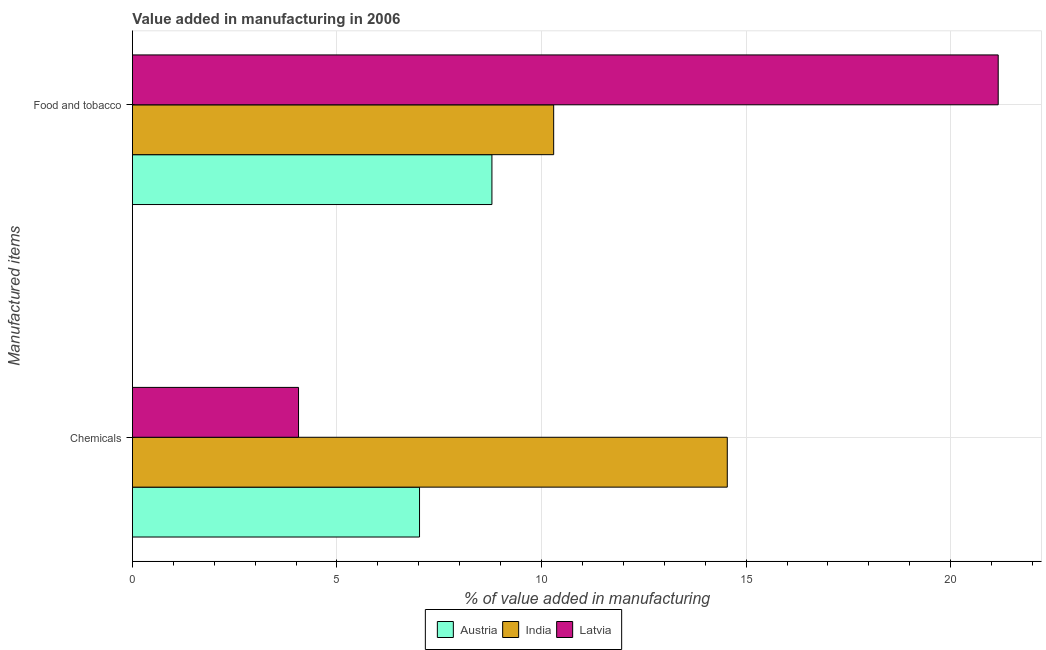How many different coloured bars are there?
Offer a very short reply. 3. Are the number of bars on each tick of the Y-axis equal?
Provide a short and direct response. Yes. How many bars are there on the 2nd tick from the top?
Keep it short and to the point. 3. What is the label of the 1st group of bars from the top?
Your answer should be compact. Food and tobacco. What is the value added by manufacturing food and tobacco in Austria?
Ensure brevity in your answer.  8.79. Across all countries, what is the maximum value added by manufacturing food and tobacco?
Your answer should be very brief. 21.16. Across all countries, what is the minimum value added by  manufacturing chemicals?
Ensure brevity in your answer.  4.06. In which country was the value added by  manufacturing chemicals maximum?
Your answer should be very brief. India. In which country was the value added by  manufacturing chemicals minimum?
Your answer should be very brief. Latvia. What is the total value added by manufacturing food and tobacco in the graph?
Offer a very short reply. 40.25. What is the difference between the value added by  manufacturing chemicals in Latvia and that in India?
Provide a succinct answer. -10.48. What is the difference between the value added by  manufacturing chemicals in Austria and the value added by manufacturing food and tobacco in Latvia?
Provide a succinct answer. -14.15. What is the average value added by manufacturing food and tobacco per country?
Your response must be concise. 13.42. What is the difference between the value added by  manufacturing chemicals and value added by manufacturing food and tobacco in Latvia?
Your answer should be very brief. -17.1. What is the ratio of the value added by  manufacturing chemicals in India to that in Austria?
Give a very brief answer. 2.07. Is the value added by  manufacturing chemicals in India less than that in Latvia?
Your answer should be compact. No. What does the 2nd bar from the top in Food and tobacco represents?
Offer a terse response. India. How many countries are there in the graph?
Your answer should be compact. 3. Are the values on the major ticks of X-axis written in scientific E-notation?
Make the answer very short. No. How many legend labels are there?
Your answer should be compact. 3. What is the title of the graph?
Keep it short and to the point. Value added in manufacturing in 2006. What is the label or title of the X-axis?
Your answer should be compact. % of value added in manufacturing. What is the label or title of the Y-axis?
Your answer should be compact. Manufactured items. What is the % of value added in manufacturing of Austria in Chemicals?
Provide a succinct answer. 7.02. What is the % of value added in manufacturing of India in Chemicals?
Ensure brevity in your answer.  14.54. What is the % of value added in manufacturing of Latvia in Chemicals?
Provide a succinct answer. 4.06. What is the % of value added in manufacturing in Austria in Food and tobacco?
Your answer should be very brief. 8.79. What is the % of value added in manufacturing of India in Food and tobacco?
Provide a succinct answer. 10.3. What is the % of value added in manufacturing in Latvia in Food and tobacco?
Offer a very short reply. 21.16. Across all Manufactured items, what is the maximum % of value added in manufacturing in Austria?
Make the answer very short. 8.79. Across all Manufactured items, what is the maximum % of value added in manufacturing in India?
Ensure brevity in your answer.  14.54. Across all Manufactured items, what is the maximum % of value added in manufacturing of Latvia?
Your answer should be compact. 21.16. Across all Manufactured items, what is the minimum % of value added in manufacturing in Austria?
Provide a short and direct response. 7.02. Across all Manufactured items, what is the minimum % of value added in manufacturing of India?
Provide a succinct answer. 10.3. Across all Manufactured items, what is the minimum % of value added in manufacturing of Latvia?
Offer a terse response. 4.06. What is the total % of value added in manufacturing in Austria in the graph?
Give a very brief answer. 15.8. What is the total % of value added in manufacturing in India in the graph?
Keep it short and to the point. 24.84. What is the total % of value added in manufacturing in Latvia in the graph?
Your answer should be very brief. 25.22. What is the difference between the % of value added in manufacturing in Austria in Chemicals and that in Food and tobacco?
Give a very brief answer. -1.77. What is the difference between the % of value added in manufacturing of India in Chemicals and that in Food and tobacco?
Give a very brief answer. 4.24. What is the difference between the % of value added in manufacturing in Latvia in Chemicals and that in Food and tobacco?
Make the answer very short. -17.1. What is the difference between the % of value added in manufacturing in Austria in Chemicals and the % of value added in manufacturing in India in Food and tobacco?
Your response must be concise. -3.28. What is the difference between the % of value added in manufacturing of Austria in Chemicals and the % of value added in manufacturing of Latvia in Food and tobacco?
Provide a succinct answer. -14.15. What is the difference between the % of value added in manufacturing in India in Chemicals and the % of value added in manufacturing in Latvia in Food and tobacco?
Give a very brief answer. -6.62. What is the average % of value added in manufacturing of Austria per Manufactured items?
Your response must be concise. 7.9. What is the average % of value added in manufacturing of India per Manufactured items?
Your response must be concise. 12.42. What is the average % of value added in manufacturing of Latvia per Manufactured items?
Offer a terse response. 12.61. What is the difference between the % of value added in manufacturing in Austria and % of value added in manufacturing in India in Chemicals?
Offer a very short reply. -7.52. What is the difference between the % of value added in manufacturing of Austria and % of value added in manufacturing of Latvia in Chemicals?
Keep it short and to the point. 2.96. What is the difference between the % of value added in manufacturing in India and % of value added in manufacturing in Latvia in Chemicals?
Keep it short and to the point. 10.48. What is the difference between the % of value added in manufacturing in Austria and % of value added in manufacturing in India in Food and tobacco?
Make the answer very short. -1.51. What is the difference between the % of value added in manufacturing of Austria and % of value added in manufacturing of Latvia in Food and tobacco?
Make the answer very short. -12.38. What is the difference between the % of value added in manufacturing of India and % of value added in manufacturing of Latvia in Food and tobacco?
Your answer should be compact. -10.87. What is the ratio of the % of value added in manufacturing of Austria in Chemicals to that in Food and tobacco?
Give a very brief answer. 0.8. What is the ratio of the % of value added in manufacturing of India in Chemicals to that in Food and tobacco?
Offer a very short reply. 1.41. What is the ratio of the % of value added in manufacturing of Latvia in Chemicals to that in Food and tobacco?
Provide a short and direct response. 0.19. What is the difference between the highest and the second highest % of value added in manufacturing in Austria?
Your answer should be very brief. 1.77. What is the difference between the highest and the second highest % of value added in manufacturing of India?
Provide a succinct answer. 4.24. What is the difference between the highest and the second highest % of value added in manufacturing of Latvia?
Make the answer very short. 17.1. What is the difference between the highest and the lowest % of value added in manufacturing in Austria?
Your answer should be compact. 1.77. What is the difference between the highest and the lowest % of value added in manufacturing in India?
Make the answer very short. 4.24. What is the difference between the highest and the lowest % of value added in manufacturing in Latvia?
Give a very brief answer. 17.1. 